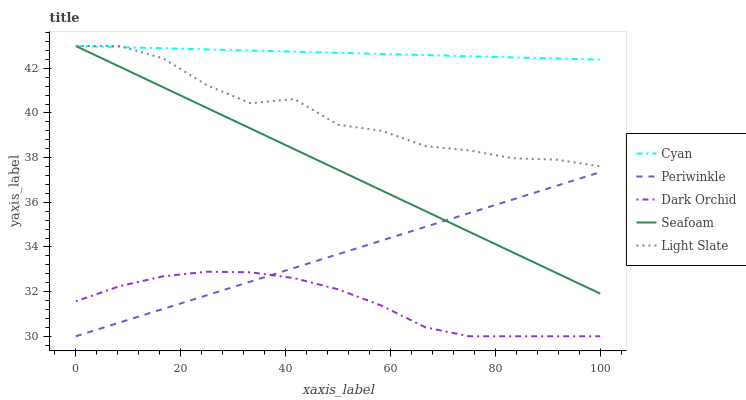Does Dark Orchid have the minimum area under the curve?
Answer yes or no. Yes. Does Cyan have the maximum area under the curve?
Answer yes or no. Yes. Does Periwinkle have the minimum area under the curve?
Answer yes or no. No. Does Periwinkle have the maximum area under the curve?
Answer yes or no. No. Is Seafoam the smoothest?
Answer yes or no. Yes. Is Light Slate the roughest?
Answer yes or no. Yes. Is Cyan the smoothest?
Answer yes or no. No. Is Cyan the roughest?
Answer yes or no. No. Does Cyan have the lowest value?
Answer yes or no. No. Does Seafoam have the highest value?
Answer yes or no. Yes. Does Periwinkle have the highest value?
Answer yes or no. No. Is Dark Orchid less than Light Slate?
Answer yes or no. Yes. Is Seafoam greater than Dark Orchid?
Answer yes or no. Yes. Does Cyan intersect Seafoam?
Answer yes or no. Yes. Is Cyan less than Seafoam?
Answer yes or no. No. Is Cyan greater than Seafoam?
Answer yes or no. No. Does Dark Orchid intersect Light Slate?
Answer yes or no. No. 